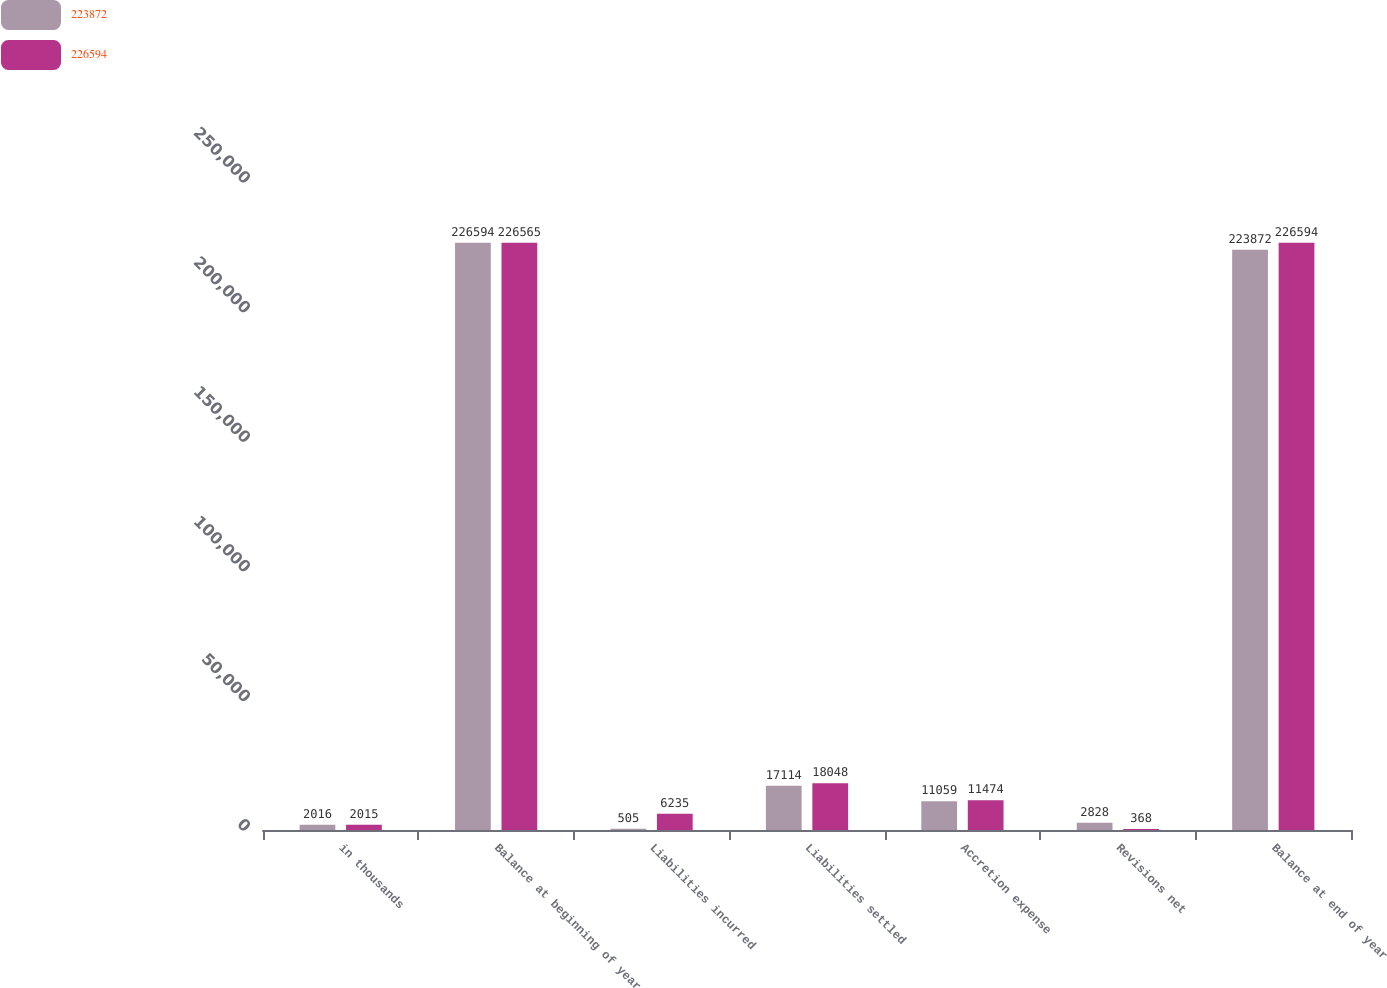Convert chart to OTSL. <chart><loc_0><loc_0><loc_500><loc_500><stacked_bar_chart><ecel><fcel>in thousands<fcel>Balance at beginning of year<fcel>Liabilities incurred<fcel>Liabilities settled<fcel>Accretion expense<fcel>Revisions net<fcel>Balance at end of year<nl><fcel>223872<fcel>2016<fcel>226594<fcel>505<fcel>17114<fcel>11059<fcel>2828<fcel>223872<nl><fcel>226594<fcel>2015<fcel>226565<fcel>6235<fcel>18048<fcel>11474<fcel>368<fcel>226594<nl></chart> 